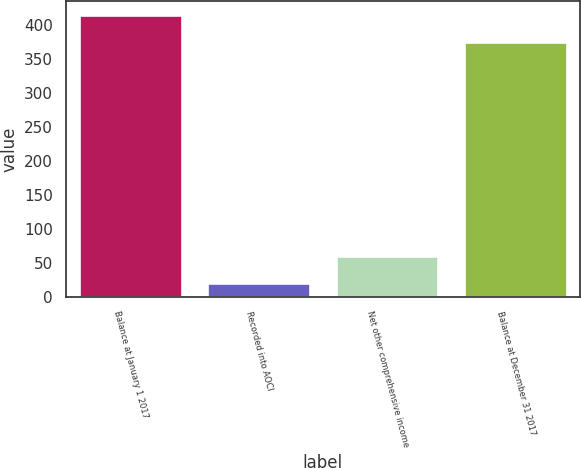Convert chart to OTSL. <chart><loc_0><loc_0><loc_500><loc_500><bar_chart><fcel>Balance at January 1 2017<fcel>Recorded into AOCI<fcel>Net other comprehensive income<fcel>Balance at December 31 2017<nl><fcel>414.97<fcel>20.4<fcel>59.77<fcel>375.6<nl></chart> 